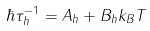<formula> <loc_0><loc_0><loc_500><loc_500>\hbar { \tau } _ { h } ^ { - 1 } = A _ { h } + B _ { h } k _ { B } T</formula> 